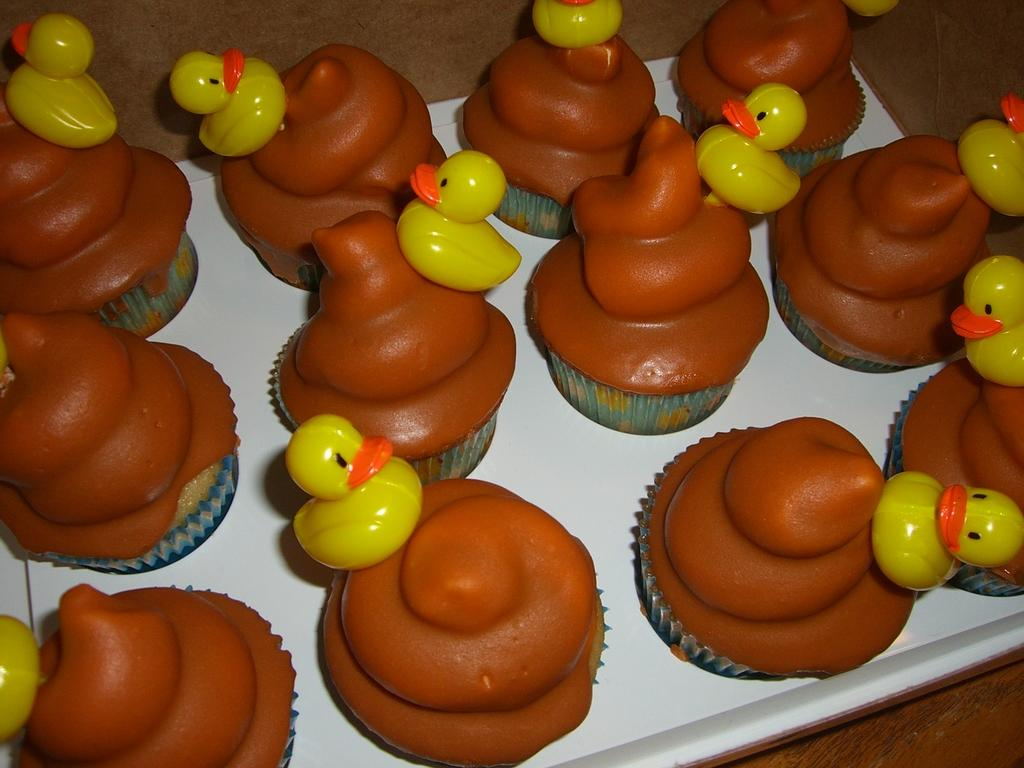What type of dessert can be seen in the image? There are cupcakes in the image. How are the cupcakes arranged or presented? The cupcakes are placed on a tray. What additional decorations are on the cupcakes? Small rubber ducks are placed on the cupcakes. What type of zebra can be seen sitting on a branch in the image? There is no zebra or branch present in the image; it features cupcakes with rubber ducks on them. What color of yarn is wrapped around the cupcakes in the image? There is no yarn present on the cupcakes in the image. 